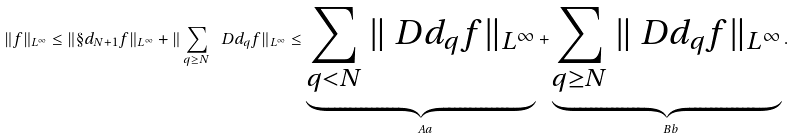<formula> <loc_0><loc_0><loc_500><loc_500>\| f \| _ { L ^ { \infty } } \leq \| \S d _ { N + 1 } f \| _ { L ^ { \infty } } + \| \sum _ { q \geq N } \ D d _ { q } f \| _ { L ^ { \infty } } \leq \underbrace { \sum _ { q < N } \| \ D d _ { q } f \| _ { L ^ { \infty } } } _ { \ A a } + \underbrace { \sum _ { q \geq N } \| \ D d _ { q } f \| _ { L ^ { \infty } } } _ { \ B b } .</formula> 